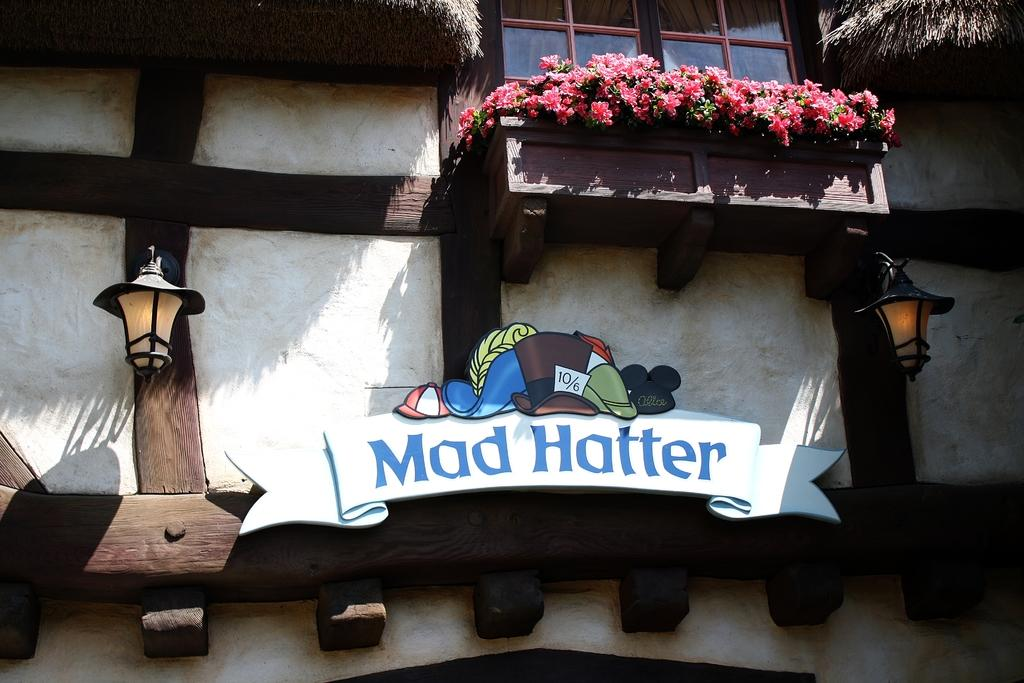What structure is visible in the image? There is a building in the image. What can be seen on the building? There are lights and plants on the building. Are there any specific features of the plants on the building? Yes, there are flowers on the building. Can you tell me how deep the river is in the image? There is no river present in the image; it features a building with lights, plants, and flowers. 